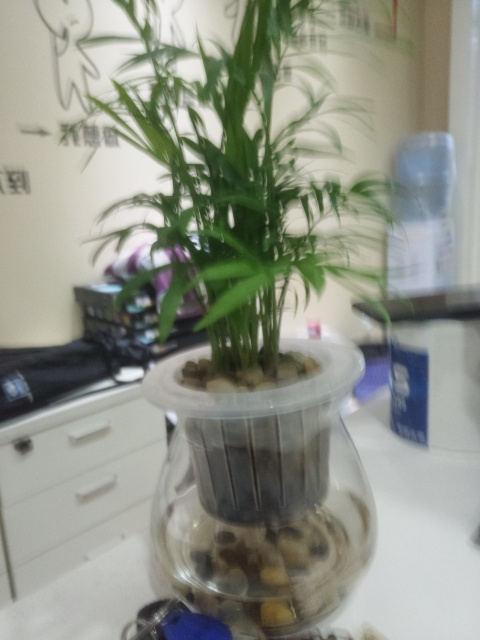What kind of plant is shown in the image, and where is it most likely located? The image displays a plant that resembles a type of palm, often found indoors for decorative purposes. Judging by the objects in the background and writing on the wall, it could be located in an office or a domestic setting, possibly in a region where the script on the wall is commonly used. 